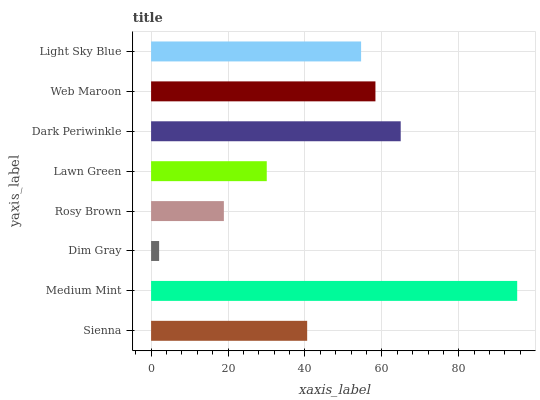Is Dim Gray the minimum?
Answer yes or no. Yes. Is Medium Mint the maximum?
Answer yes or no. Yes. Is Medium Mint the minimum?
Answer yes or no. No. Is Dim Gray the maximum?
Answer yes or no. No. Is Medium Mint greater than Dim Gray?
Answer yes or no. Yes. Is Dim Gray less than Medium Mint?
Answer yes or no. Yes. Is Dim Gray greater than Medium Mint?
Answer yes or no. No. Is Medium Mint less than Dim Gray?
Answer yes or no. No. Is Light Sky Blue the high median?
Answer yes or no. Yes. Is Sienna the low median?
Answer yes or no. Yes. Is Web Maroon the high median?
Answer yes or no. No. Is Medium Mint the low median?
Answer yes or no. No. 